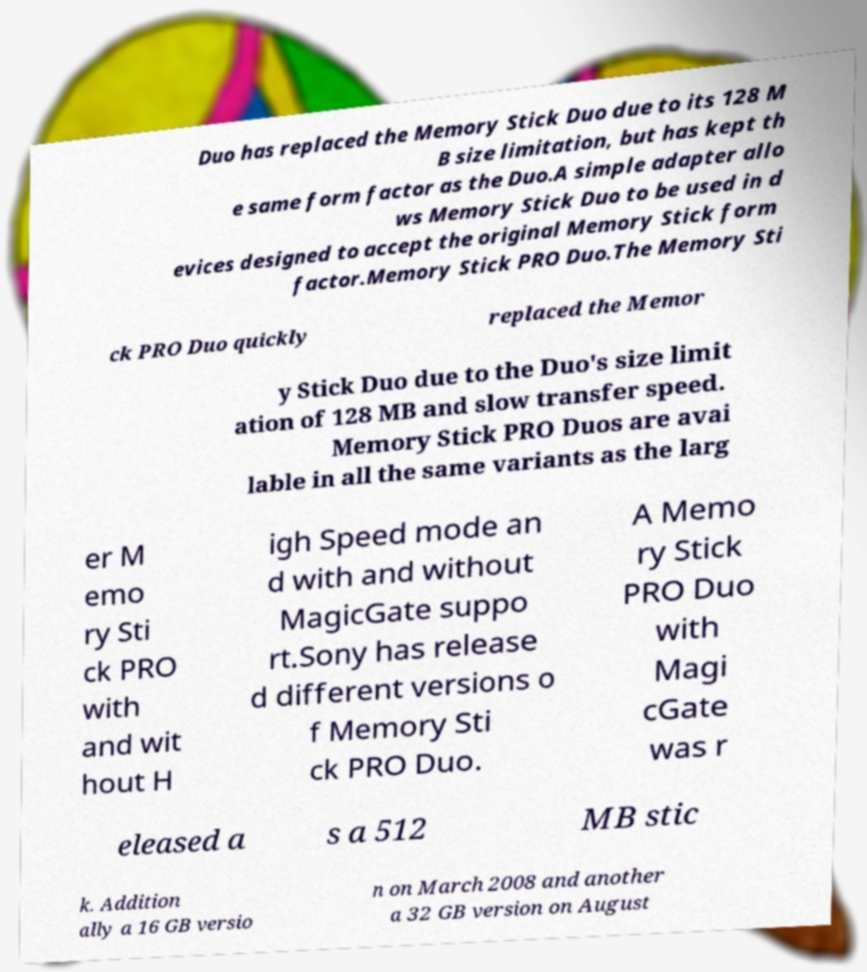I need the written content from this picture converted into text. Can you do that? Duo has replaced the Memory Stick Duo due to its 128 M B size limitation, but has kept th e same form factor as the Duo.A simple adapter allo ws Memory Stick Duo to be used in d evices designed to accept the original Memory Stick form factor.Memory Stick PRO Duo.The Memory Sti ck PRO Duo quickly replaced the Memor y Stick Duo due to the Duo's size limit ation of 128 MB and slow transfer speed. Memory Stick PRO Duos are avai lable in all the same variants as the larg er M emo ry Sti ck PRO with and wit hout H igh Speed mode an d with and without MagicGate suppo rt.Sony has release d different versions o f Memory Sti ck PRO Duo. A Memo ry Stick PRO Duo with Magi cGate was r eleased a s a 512 MB stic k. Addition ally a 16 GB versio n on March 2008 and another a 32 GB version on August 